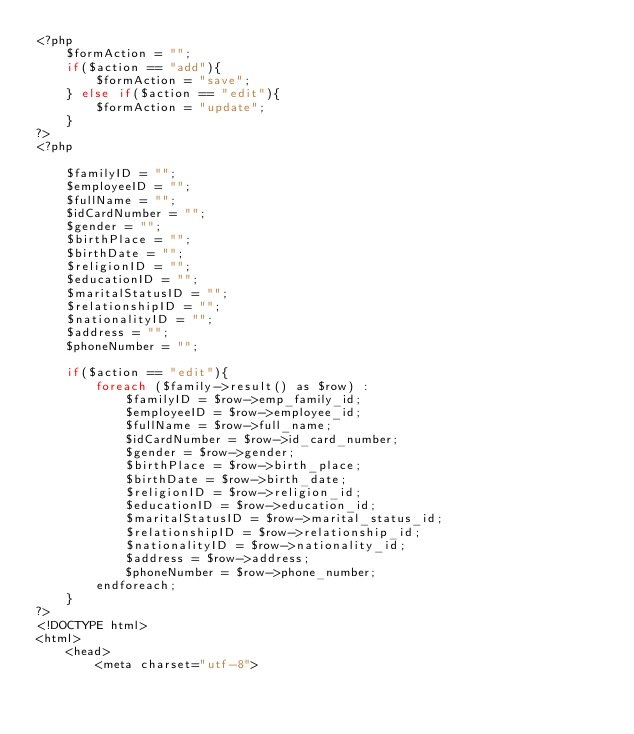Convert code to text. <code><loc_0><loc_0><loc_500><loc_500><_PHP_><?php       
    $formAction = "";                          
    if($action == "add"){                                
        $formAction = "save";                                        
    } else if($action == "edit"){                                
        $formAction = "update";                                        
    }
?>
<?php    

    $familyID = "";
    $employeeID = "";    
    $fullName = "";
    $idCardNumber = "";
    $gender = "";
    $birthPlace = "";
    $birthDate = "";
    $religionID = "";
    $educationID = "";
    $maritalStatusID = "";
    $relationshipID = "";
    $nationalityID = "";   
    $address = "";
    $phoneNumber = "";        

    if($action == "edit"){
        foreach ($family->result() as $row) :             
            $familyID = $row->emp_family_id;
            $employeeID = $row->employee_id;              
            $fullName = $row->full_name;
            $idCardNumber = $row->id_card_number;
            $gender = $row->gender;
            $birthPlace = $row->birth_place;    
            $birthDate = $row->birth_date;    
            $religionID = $row->religion_id;         
            $educationID = $row->education_id;         
            $maritalStatusID = $row->marital_status_id;         
            $relationshipID = $row->relationship_id;         
            $nationalityID = $row->nationality_id;    
            $address = $row->address;
            $phoneNumber = $row->phone_number;            
        endforeach;
    }
?>
<!DOCTYPE html>
<html>
    <head>
        <meta charset="utf-8"></code> 